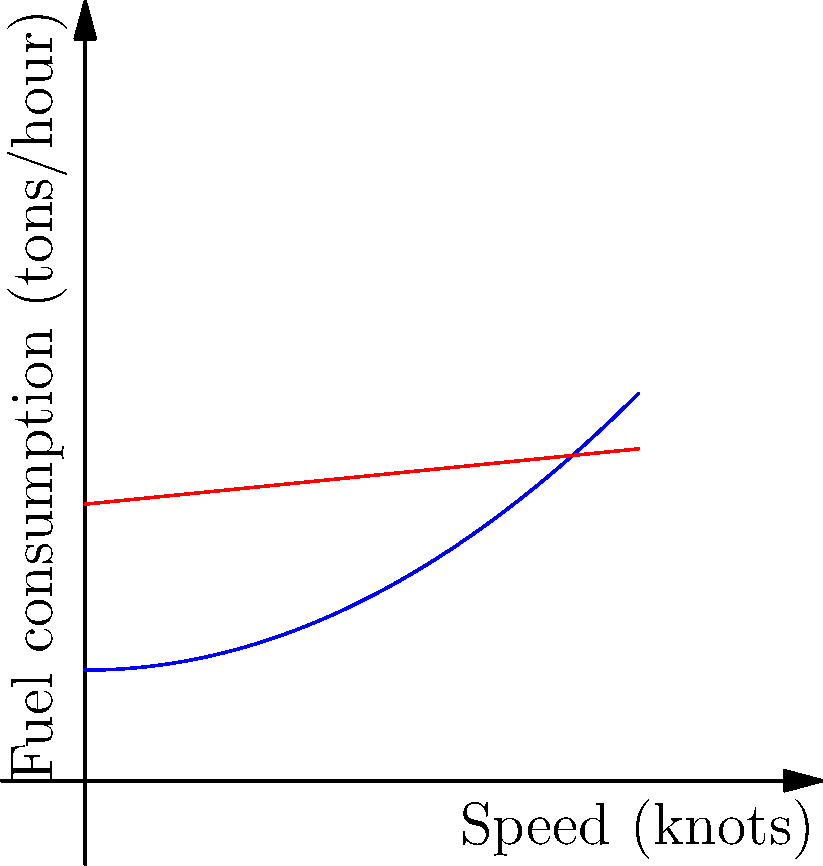The graph shows the fuel consumption rates for a destroyer and a frigate as functions of their speeds. The destroyer's fuel consumption (in tons per hour) is given by $f(x) = 0.05x^2 + 2$, where $x$ is the speed in knots. If the destroyer increases its speed from 15 to 20 knots over a 30-minute period, what is the average rate of change in fuel consumption during this time? To find the average rate of change in fuel consumption, we need to follow these steps:

1) Calculate the fuel consumption at 15 knots:
   $f(15) = 0.05(15^2) + 2 = 0.05(225) + 2 = 11.25 + 2 = 13.25$ tons/hour

2) Calculate the fuel consumption at 20 knots:
   $f(20) = 0.05(20^2) + 2 = 0.05(400) + 2 = 20 + 2 = 22$ tons/hour

3) Calculate the change in fuel consumption:
   $\Delta f = f(20) - f(15) = 22 - 13.25 = 8.75$ tons/hour

4) Calculate the change in time:
   The speed increase occurs over 30 minutes, which is 0.5 hours.

5) Calculate the average rate of change:
   Average rate of change = $\frac{\Delta f}{\Delta t} = \frac{8.75}{0.5} = 17.5$ tons/hour²

Therefore, the average rate of change in fuel consumption is 17.5 tons per hour per hour.
Answer: 17.5 tons/hour² 